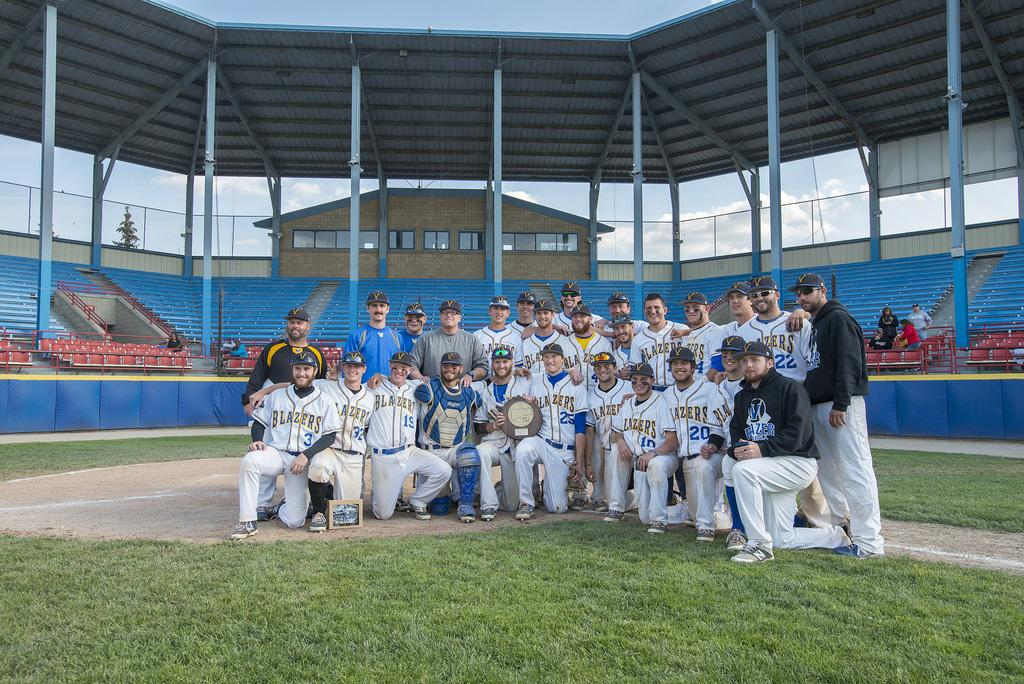<image>
Offer a succinct explanation of the picture presented. baseball team the Blazers posing for a photo 